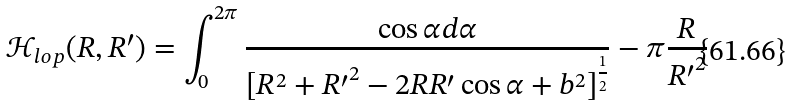Convert formula to latex. <formula><loc_0><loc_0><loc_500><loc_500>\mathcal { H } _ { l o p } ( R , R ^ { \prime } ) = \int _ { 0 } ^ { 2 \pi } \frac { \cos { \alpha } d \alpha } { [ R ^ { 2 } + { R ^ { \prime } } ^ { 2 } - 2 R R ^ { \prime } \cos { \alpha } + b ^ { 2 } ] ^ { \frac { 1 } { 2 } } } - \pi \frac { R } { { R ^ { \prime } } ^ { 2 } }</formula> 